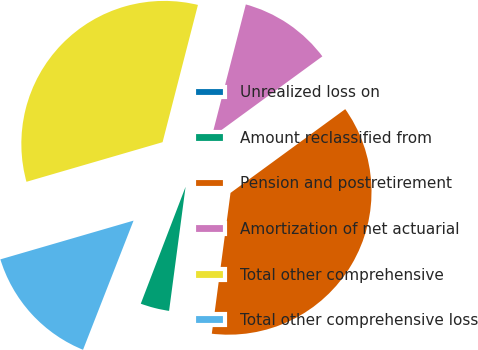<chart> <loc_0><loc_0><loc_500><loc_500><pie_chart><fcel>Unrealized loss on<fcel>Amount reclassified from<fcel>Pension and postretirement<fcel>Amortization of net actuarial<fcel>Total other comprehensive<fcel>Total other comprehensive loss<nl><fcel>0.11%<fcel>3.72%<fcel>37.14%<fcel>10.95%<fcel>33.52%<fcel>14.56%<nl></chart> 